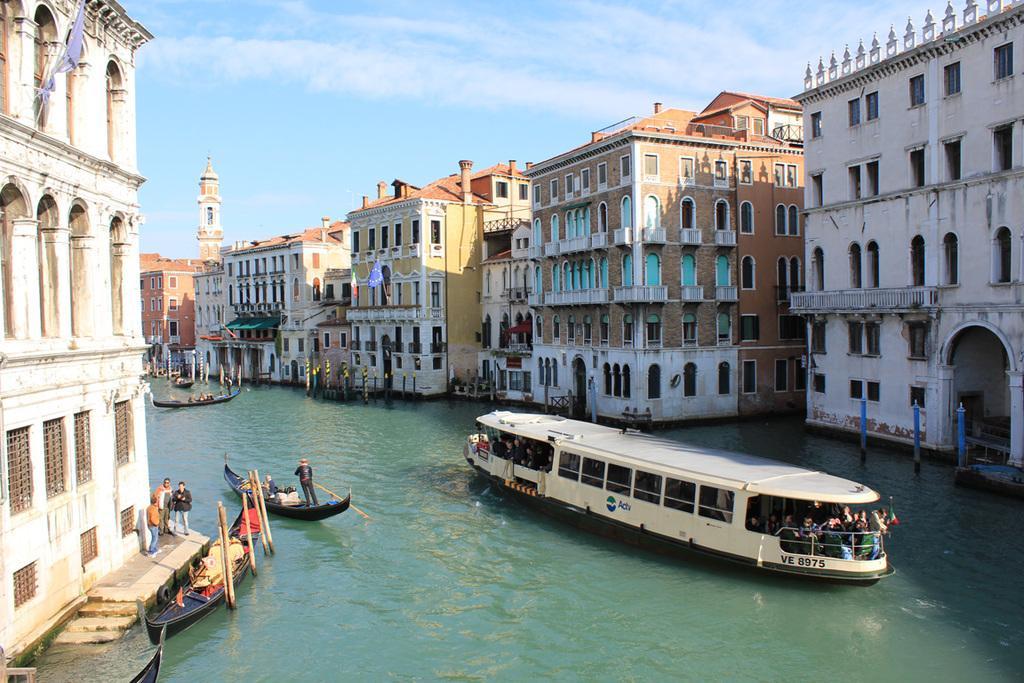Describe this image in one or two sentences. In this image we can see sky with clouds, buildings, boats and ship on the water and persons standing on them by holding rows in their hands, persons standing on the floor and barrier poles. 